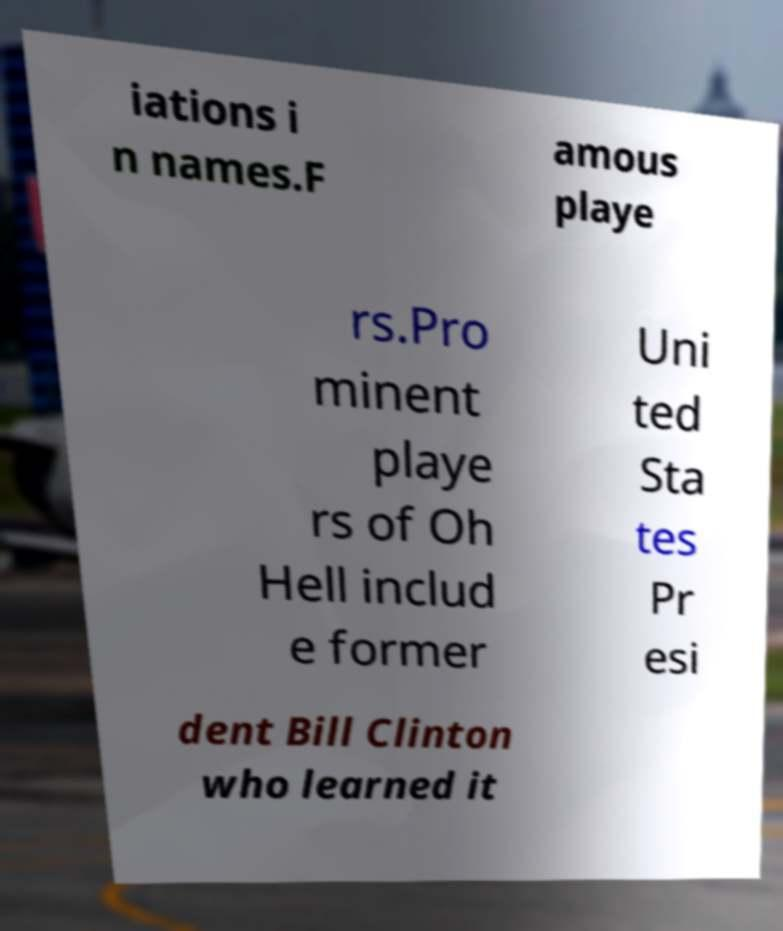For documentation purposes, I need the text within this image transcribed. Could you provide that? iations i n names.F amous playe rs.Pro minent playe rs of Oh Hell includ e former Uni ted Sta tes Pr esi dent Bill Clinton who learned it 